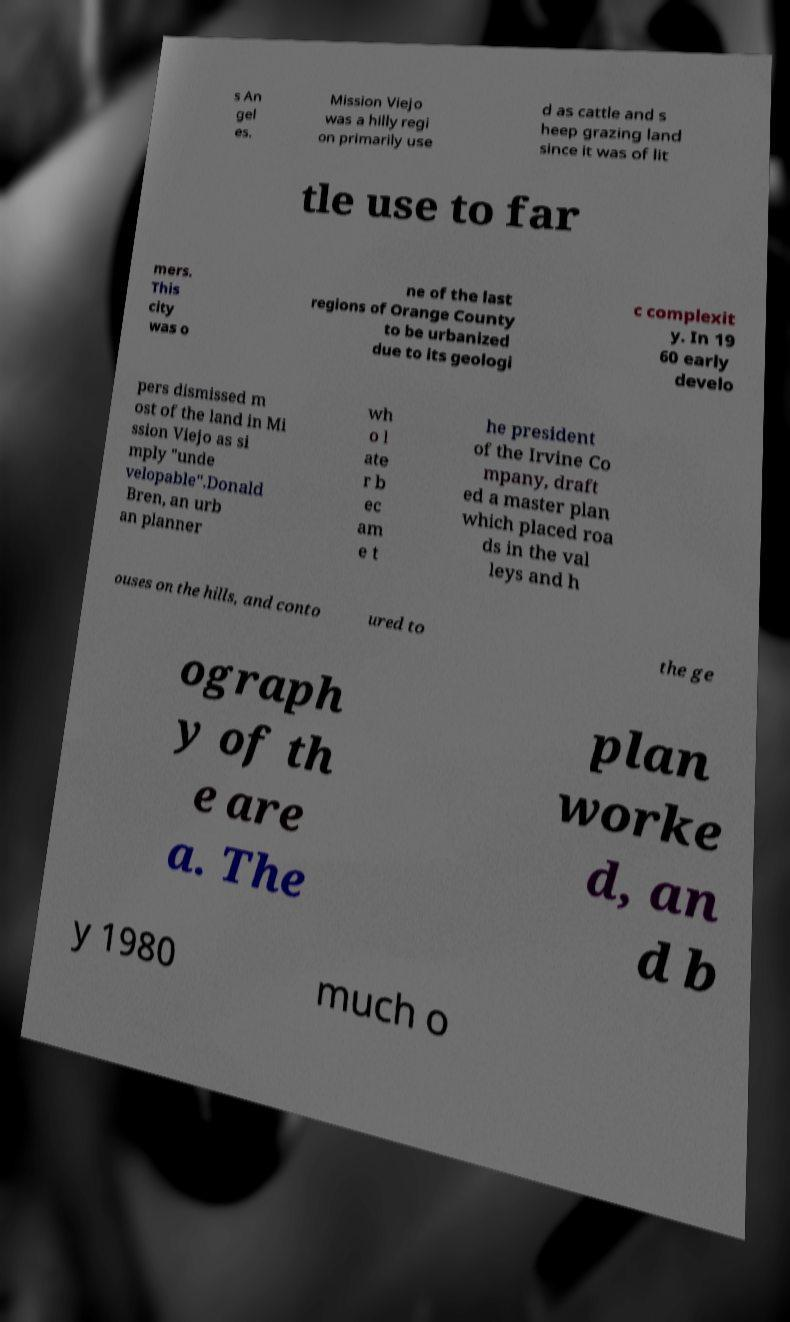I need the written content from this picture converted into text. Can you do that? s An gel es. Mission Viejo was a hilly regi on primarily use d as cattle and s heep grazing land since it was of lit tle use to far mers. This city was o ne of the last regions of Orange County to be urbanized due to its geologi c complexit y. In 19 60 early develo pers dismissed m ost of the land in Mi ssion Viejo as si mply "unde velopable".Donald Bren, an urb an planner wh o l ate r b ec am e t he president of the Irvine Co mpany, draft ed a master plan which placed roa ds in the val leys and h ouses on the hills, and conto ured to the ge ograph y of th e are a. The plan worke d, an d b y 1980 much o 